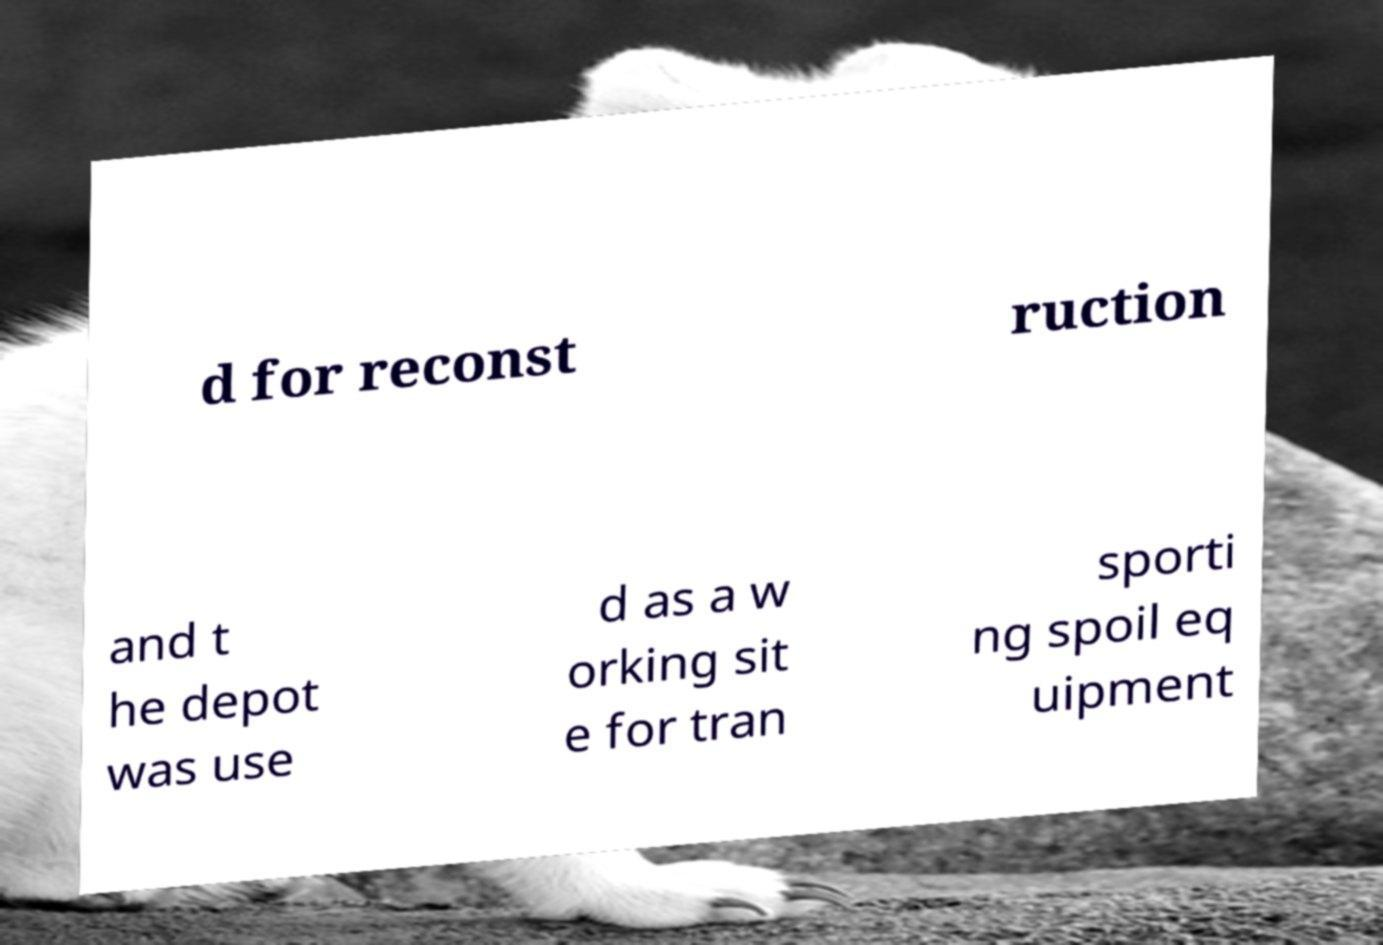Please identify and transcribe the text found in this image. d for reconst ruction and t he depot was use d as a w orking sit e for tran sporti ng spoil eq uipment 